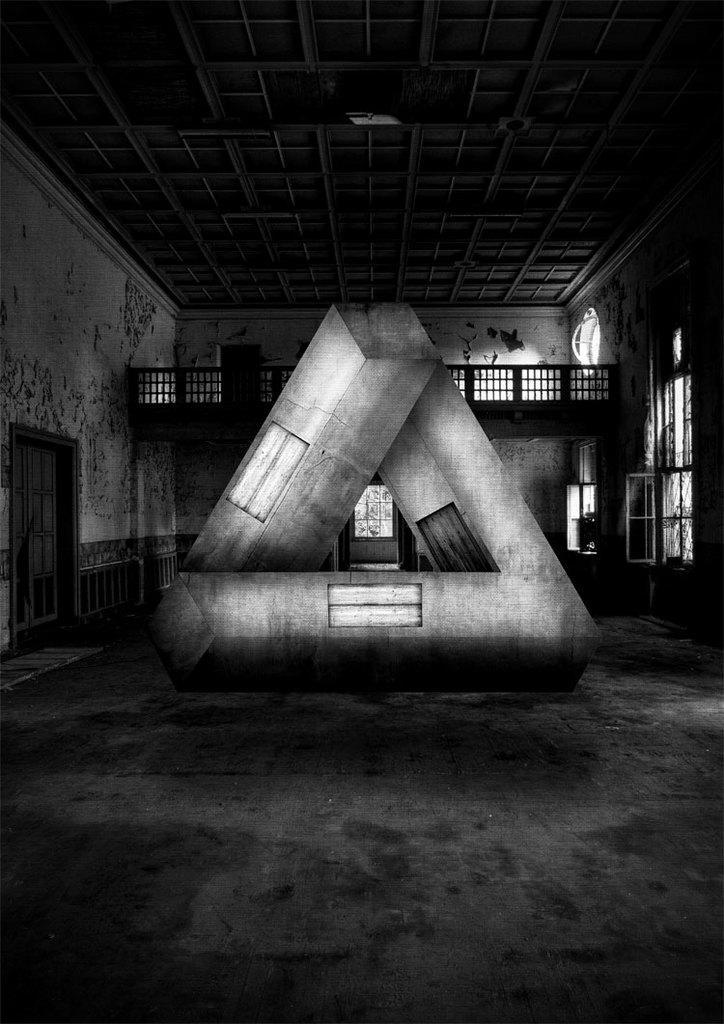Could you give a brief overview of what you see in this image? This is a black and white picture. Here we can see an object which is in triangular shape. There is a door and this is wall. Here we can see windows and this is roof. 